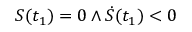<formula> <loc_0><loc_0><loc_500><loc_500>S ( t _ { 1 } ) = 0 \land \dot { S } ( t _ { 1 } ) < 0</formula> 